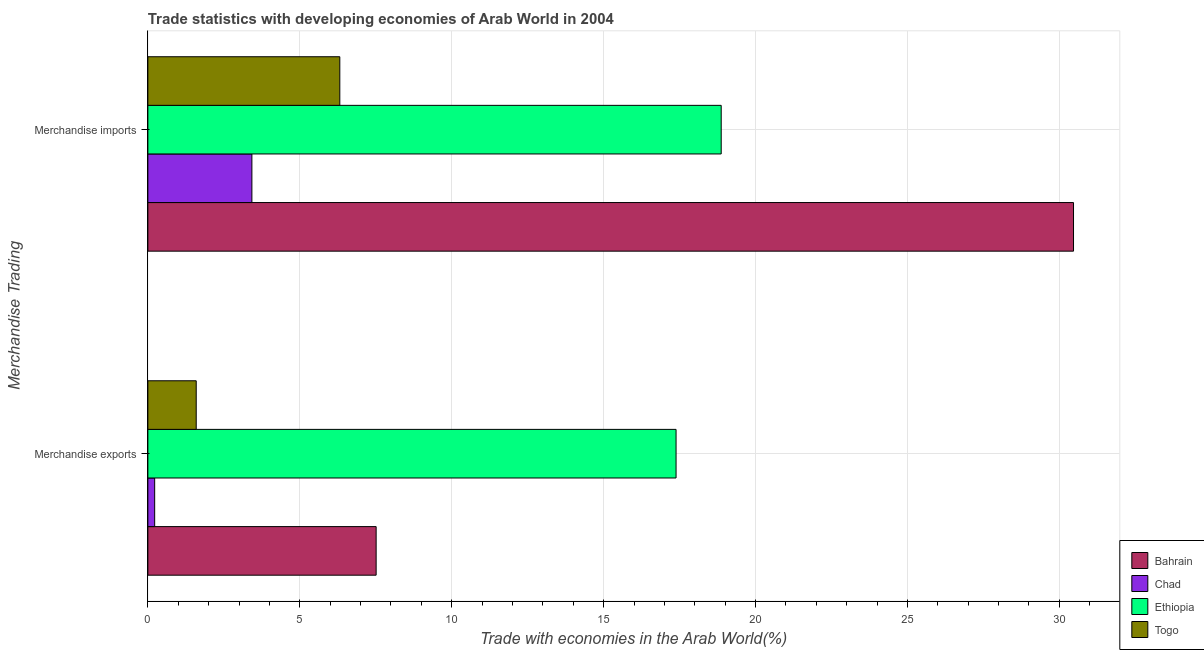Are the number of bars per tick equal to the number of legend labels?
Keep it short and to the point. Yes. Are the number of bars on each tick of the Y-axis equal?
Provide a succinct answer. Yes. How many bars are there on the 1st tick from the top?
Make the answer very short. 4. What is the label of the 2nd group of bars from the top?
Your response must be concise. Merchandise exports. What is the merchandise exports in Chad?
Provide a short and direct response. 0.22. Across all countries, what is the maximum merchandise imports?
Provide a short and direct response. 30.47. Across all countries, what is the minimum merchandise exports?
Make the answer very short. 0.22. In which country was the merchandise exports maximum?
Make the answer very short. Ethiopia. In which country was the merchandise imports minimum?
Provide a succinct answer. Chad. What is the total merchandise imports in the graph?
Offer a terse response. 59.08. What is the difference between the merchandise imports in Togo and that in Chad?
Keep it short and to the point. 2.89. What is the difference between the merchandise exports in Chad and the merchandise imports in Bahrain?
Your response must be concise. -30.24. What is the average merchandise exports per country?
Offer a very short reply. 6.68. What is the difference between the merchandise imports and merchandise exports in Bahrain?
Offer a terse response. 22.95. In how many countries, is the merchandise exports greater than 18 %?
Provide a succinct answer. 0. What is the ratio of the merchandise imports in Togo to that in Ethiopia?
Provide a succinct answer. 0.33. Is the merchandise imports in Bahrain less than that in Togo?
Keep it short and to the point. No. What does the 4th bar from the top in Merchandise imports represents?
Your response must be concise. Bahrain. What does the 3rd bar from the bottom in Merchandise exports represents?
Provide a succinct answer. Ethiopia. How many bars are there?
Ensure brevity in your answer.  8. Are all the bars in the graph horizontal?
Your answer should be very brief. Yes. How many countries are there in the graph?
Offer a terse response. 4. Does the graph contain any zero values?
Provide a short and direct response. No. Where does the legend appear in the graph?
Make the answer very short. Bottom right. How many legend labels are there?
Give a very brief answer. 4. How are the legend labels stacked?
Offer a terse response. Vertical. What is the title of the graph?
Keep it short and to the point. Trade statistics with developing economies of Arab World in 2004. What is the label or title of the X-axis?
Offer a very short reply. Trade with economies in the Arab World(%). What is the label or title of the Y-axis?
Give a very brief answer. Merchandise Trading. What is the Trade with economies in the Arab World(%) in Bahrain in Merchandise exports?
Ensure brevity in your answer.  7.51. What is the Trade with economies in the Arab World(%) of Chad in Merchandise exports?
Keep it short and to the point. 0.22. What is the Trade with economies in the Arab World(%) in Ethiopia in Merchandise exports?
Ensure brevity in your answer.  17.38. What is the Trade with economies in the Arab World(%) of Togo in Merchandise exports?
Ensure brevity in your answer.  1.59. What is the Trade with economies in the Arab World(%) of Bahrain in Merchandise imports?
Offer a terse response. 30.47. What is the Trade with economies in the Arab World(%) of Chad in Merchandise imports?
Ensure brevity in your answer.  3.42. What is the Trade with economies in the Arab World(%) in Ethiopia in Merchandise imports?
Your response must be concise. 18.87. What is the Trade with economies in the Arab World(%) in Togo in Merchandise imports?
Your answer should be compact. 6.32. Across all Merchandise Trading, what is the maximum Trade with economies in the Arab World(%) in Bahrain?
Your answer should be compact. 30.47. Across all Merchandise Trading, what is the maximum Trade with economies in the Arab World(%) of Chad?
Keep it short and to the point. 3.42. Across all Merchandise Trading, what is the maximum Trade with economies in the Arab World(%) of Ethiopia?
Offer a very short reply. 18.87. Across all Merchandise Trading, what is the maximum Trade with economies in the Arab World(%) in Togo?
Provide a succinct answer. 6.32. Across all Merchandise Trading, what is the minimum Trade with economies in the Arab World(%) of Bahrain?
Make the answer very short. 7.51. Across all Merchandise Trading, what is the minimum Trade with economies in the Arab World(%) in Chad?
Your response must be concise. 0.22. Across all Merchandise Trading, what is the minimum Trade with economies in the Arab World(%) in Ethiopia?
Provide a short and direct response. 17.38. Across all Merchandise Trading, what is the minimum Trade with economies in the Arab World(%) of Togo?
Provide a short and direct response. 1.59. What is the total Trade with economies in the Arab World(%) in Bahrain in the graph?
Your answer should be very brief. 37.98. What is the total Trade with economies in the Arab World(%) in Chad in the graph?
Your answer should be compact. 3.65. What is the total Trade with economies in the Arab World(%) of Ethiopia in the graph?
Provide a short and direct response. 36.25. What is the total Trade with economies in the Arab World(%) in Togo in the graph?
Your response must be concise. 7.91. What is the difference between the Trade with economies in the Arab World(%) in Bahrain in Merchandise exports and that in Merchandise imports?
Give a very brief answer. -22.95. What is the difference between the Trade with economies in the Arab World(%) of Chad in Merchandise exports and that in Merchandise imports?
Provide a succinct answer. -3.2. What is the difference between the Trade with economies in the Arab World(%) of Ethiopia in Merchandise exports and that in Merchandise imports?
Give a very brief answer. -1.49. What is the difference between the Trade with economies in the Arab World(%) of Togo in Merchandise exports and that in Merchandise imports?
Your response must be concise. -4.73. What is the difference between the Trade with economies in the Arab World(%) in Bahrain in Merchandise exports and the Trade with economies in the Arab World(%) in Chad in Merchandise imports?
Ensure brevity in your answer.  4.09. What is the difference between the Trade with economies in the Arab World(%) of Bahrain in Merchandise exports and the Trade with economies in the Arab World(%) of Ethiopia in Merchandise imports?
Your answer should be compact. -11.36. What is the difference between the Trade with economies in the Arab World(%) of Bahrain in Merchandise exports and the Trade with economies in the Arab World(%) of Togo in Merchandise imports?
Offer a very short reply. 1.2. What is the difference between the Trade with economies in the Arab World(%) in Chad in Merchandise exports and the Trade with economies in the Arab World(%) in Ethiopia in Merchandise imports?
Ensure brevity in your answer.  -18.65. What is the difference between the Trade with economies in the Arab World(%) of Chad in Merchandise exports and the Trade with economies in the Arab World(%) of Togo in Merchandise imports?
Your response must be concise. -6.09. What is the difference between the Trade with economies in the Arab World(%) of Ethiopia in Merchandise exports and the Trade with economies in the Arab World(%) of Togo in Merchandise imports?
Your answer should be compact. 11.07. What is the average Trade with economies in the Arab World(%) in Bahrain per Merchandise Trading?
Make the answer very short. 18.99. What is the average Trade with economies in the Arab World(%) of Chad per Merchandise Trading?
Provide a short and direct response. 1.82. What is the average Trade with economies in the Arab World(%) in Ethiopia per Merchandise Trading?
Ensure brevity in your answer.  18.13. What is the average Trade with economies in the Arab World(%) of Togo per Merchandise Trading?
Your response must be concise. 3.95. What is the difference between the Trade with economies in the Arab World(%) of Bahrain and Trade with economies in the Arab World(%) of Chad in Merchandise exports?
Your response must be concise. 7.29. What is the difference between the Trade with economies in the Arab World(%) in Bahrain and Trade with economies in the Arab World(%) in Ethiopia in Merchandise exports?
Offer a very short reply. -9.87. What is the difference between the Trade with economies in the Arab World(%) of Bahrain and Trade with economies in the Arab World(%) of Togo in Merchandise exports?
Your response must be concise. 5.92. What is the difference between the Trade with economies in the Arab World(%) in Chad and Trade with economies in the Arab World(%) in Ethiopia in Merchandise exports?
Offer a terse response. -17.16. What is the difference between the Trade with economies in the Arab World(%) in Chad and Trade with economies in the Arab World(%) in Togo in Merchandise exports?
Ensure brevity in your answer.  -1.37. What is the difference between the Trade with economies in the Arab World(%) in Ethiopia and Trade with economies in the Arab World(%) in Togo in Merchandise exports?
Give a very brief answer. 15.79. What is the difference between the Trade with economies in the Arab World(%) of Bahrain and Trade with economies in the Arab World(%) of Chad in Merchandise imports?
Provide a short and direct response. 27.04. What is the difference between the Trade with economies in the Arab World(%) in Bahrain and Trade with economies in the Arab World(%) in Ethiopia in Merchandise imports?
Provide a short and direct response. 11.6. What is the difference between the Trade with economies in the Arab World(%) in Bahrain and Trade with economies in the Arab World(%) in Togo in Merchandise imports?
Your response must be concise. 24.15. What is the difference between the Trade with economies in the Arab World(%) of Chad and Trade with economies in the Arab World(%) of Ethiopia in Merchandise imports?
Your answer should be compact. -15.45. What is the difference between the Trade with economies in the Arab World(%) in Chad and Trade with economies in the Arab World(%) in Togo in Merchandise imports?
Offer a terse response. -2.89. What is the difference between the Trade with economies in the Arab World(%) in Ethiopia and Trade with economies in the Arab World(%) in Togo in Merchandise imports?
Keep it short and to the point. 12.55. What is the ratio of the Trade with economies in the Arab World(%) of Bahrain in Merchandise exports to that in Merchandise imports?
Make the answer very short. 0.25. What is the ratio of the Trade with economies in the Arab World(%) in Chad in Merchandise exports to that in Merchandise imports?
Your response must be concise. 0.07. What is the ratio of the Trade with economies in the Arab World(%) in Ethiopia in Merchandise exports to that in Merchandise imports?
Your answer should be compact. 0.92. What is the ratio of the Trade with economies in the Arab World(%) of Togo in Merchandise exports to that in Merchandise imports?
Provide a succinct answer. 0.25. What is the difference between the highest and the second highest Trade with economies in the Arab World(%) of Bahrain?
Make the answer very short. 22.95. What is the difference between the highest and the second highest Trade with economies in the Arab World(%) in Chad?
Make the answer very short. 3.2. What is the difference between the highest and the second highest Trade with economies in the Arab World(%) of Ethiopia?
Offer a very short reply. 1.49. What is the difference between the highest and the second highest Trade with economies in the Arab World(%) of Togo?
Provide a succinct answer. 4.73. What is the difference between the highest and the lowest Trade with economies in the Arab World(%) of Bahrain?
Keep it short and to the point. 22.95. What is the difference between the highest and the lowest Trade with economies in the Arab World(%) in Chad?
Your response must be concise. 3.2. What is the difference between the highest and the lowest Trade with economies in the Arab World(%) in Ethiopia?
Offer a very short reply. 1.49. What is the difference between the highest and the lowest Trade with economies in the Arab World(%) of Togo?
Your response must be concise. 4.73. 